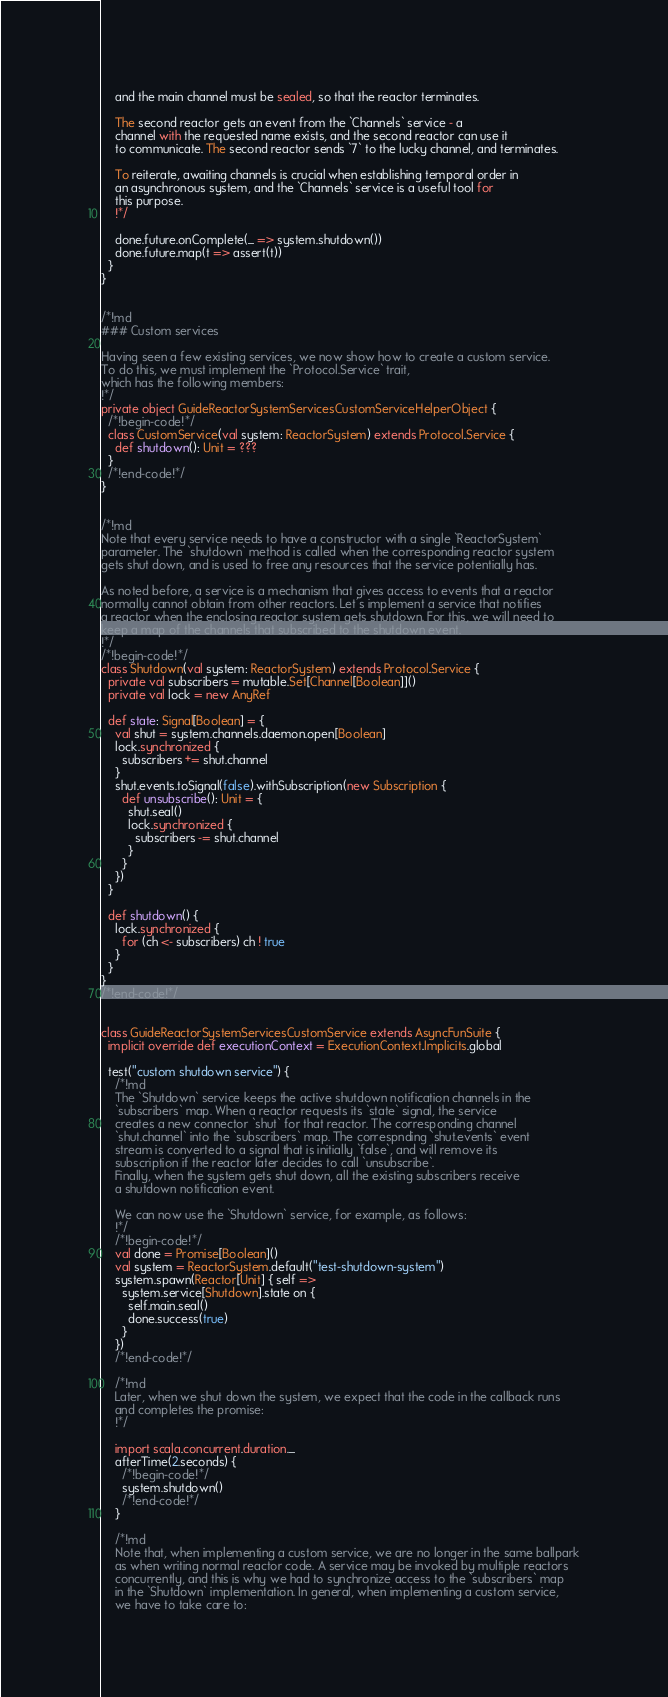Convert code to text. <code><loc_0><loc_0><loc_500><loc_500><_Scala_>    and the main channel must be sealed, so that the reactor terminates.

    The second reactor gets an event from the `Channels` service - a
    channel with the requested name exists, and the second reactor can use it
    to communicate. The second reactor sends `7` to the lucky channel, and terminates.

    To reiterate, awaiting channels is crucial when establishing temporal order in
    an asynchronous system, and the `Channels` service is a useful tool for
    this purpose.
    !*/

    done.future.onComplete(_ => system.shutdown())
    done.future.map(t => assert(t))
  }
}


/*!md
### Custom services

Having seen a few existing services, we now show how to create a custom service.
To do this, we must implement the `Protocol.Service` trait,
which has the following members:
!*/
private object GuideReactorSystemServicesCustomServiceHelperObject {
  /*!begin-code!*/
  class CustomService(val system: ReactorSystem) extends Protocol.Service {
    def shutdown(): Unit = ???
  }
  /*!end-code!*/
}


/*!md
Note that every service needs to have a constructor with a single `ReactorSystem`
parameter. The `shutdown` method is called when the corresponding reactor system
gets shut down, and is used to free any resources that the service potentially has.

As noted before, a service is a mechanism that gives access to events that a reactor
normally cannot obtain from other reactors. Let's implement a service that notifies
a reactor when the enclosing reactor system gets shutdown. For this, we will need to
keep a map of the channels that subscribed to the shutdown event.
!*/
/*!begin-code!*/
class Shutdown(val system: ReactorSystem) extends Protocol.Service {
  private val subscribers = mutable.Set[Channel[Boolean]]()
  private val lock = new AnyRef

  def state: Signal[Boolean] = {
    val shut = system.channels.daemon.open[Boolean]
    lock.synchronized {
      subscribers += shut.channel
    }
    shut.events.toSignal(false).withSubscription(new Subscription {
      def unsubscribe(): Unit = {
        shut.seal()
        lock.synchronized {
          subscribers -= shut.channel
        }
      }
    })
  }

  def shutdown() {
    lock.synchronized {
      for (ch <- subscribers) ch ! true
    }
  }
}
/*!end-code!*/


class GuideReactorSystemServicesCustomService extends AsyncFunSuite {
  implicit override def executionContext = ExecutionContext.Implicits.global

  test("custom shutdown service") {
    /*!md
    The `Shutdown` service keeps the active shutdown notification channels in the
    `subscribers` map. When a reactor requests its `state` signal, the service
    creates a new connector `shut` for that reactor. The corresponding channel
    `shut.channel` into the `subscribers` map. The correspnding `shut.events` event
    stream is converted to a signal that is initially `false`, and will remove its
    subscription if the reactor later decides to call `unsubscribe`.
    Finally, when the system gets shut down, all the existing subscribers receive
    a shutdown notification event.

    We can now use the `Shutdown` service, for example, as follows:
    !*/
    /*!begin-code!*/
    val done = Promise[Boolean]()
    val system = ReactorSystem.default("test-shutdown-system")
    system.spawn(Reactor[Unit] { self =>
      system.service[Shutdown].state on {
        self.main.seal()
        done.success(true)
      }
    })
    /*!end-code!*/

    /*!md
    Later, when we shut down the system, we expect that the code in the callback runs
    and completes the promise:
    !*/

    import scala.concurrent.duration._
    afterTime(2.seconds) {
      /*!begin-code!*/
      system.shutdown()
      /*!end-code!*/
    }

    /*!md
    Note that, when implementing a custom service, we are no longer in the same ballpark
    as when writing normal reactor code. A service may be invoked by multiple reactors
    concurrently, and this is why we had to synchronize access to the `subscribers` map
    in the `Shutdown` implementation. In general, when implementing a custom service,
    we have to take care to:
</code> 